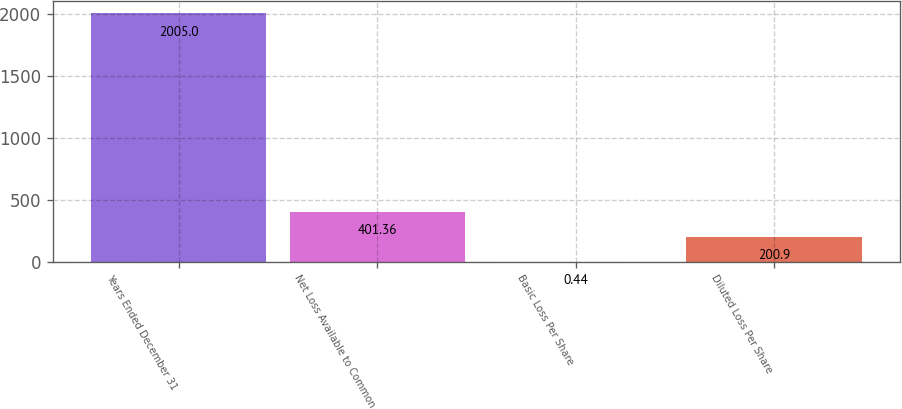<chart> <loc_0><loc_0><loc_500><loc_500><bar_chart><fcel>Years Ended December 31<fcel>Net Loss Available to Common<fcel>Basic Loss Per Share<fcel>Diluted Loss Per Share<nl><fcel>2005<fcel>401.36<fcel>0.44<fcel>200.9<nl></chart> 